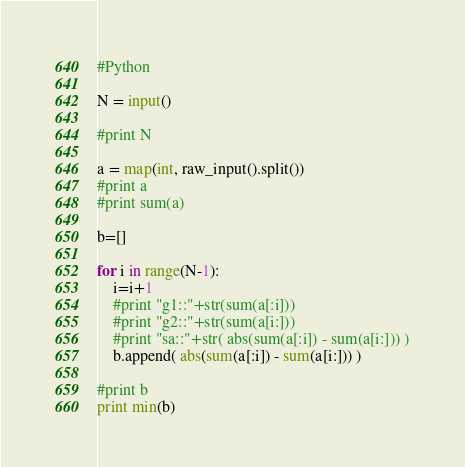<code> <loc_0><loc_0><loc_500><loc_500><_Python_>#Python

N = input()

#print N

a = map(int, raw_input().split())
#print a
#print sum(a)

b=[]

for i in range(N-1):
	i=i+1
	#print "g1::"+str(sum(a[:i]))
	#print "g2::"+str(sum(a[i:]))
	#print "sa::"+str( abs(sum(a[:i]) - sum(a[i:])) )
	b.append( abs(sum(a[:i]) - sum(a[i:])) )

#print b
print min(b)</code> 